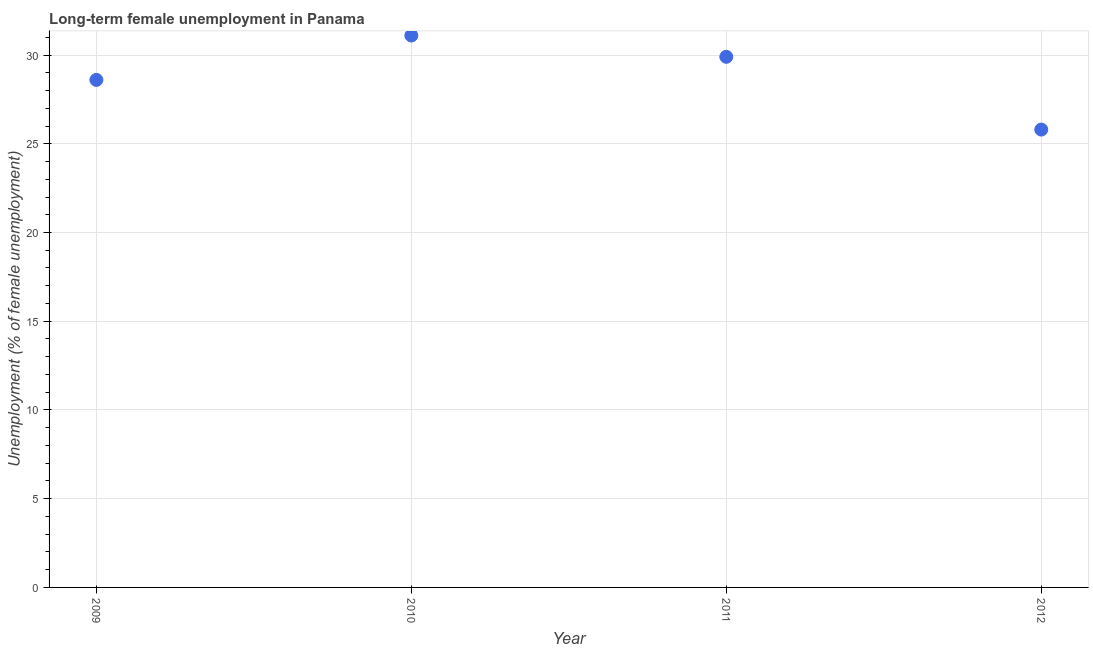What is the long-term female unemployment in 2010?
Provide a short and direct response. 31.1. Across all years, what is the maximum long-term female unemployment?
Ensure brevity in your answer.  31.1. Across all years, what is the minimum long-term female unemployment?
Ensure brevity in your answer.  25.8. In which year was the long-term female unemployment maximum?
Provide a succinct answer. 2010. What is the sum of the long-term female unemployment?
Provide a succinct answer. 115.4. What is the difference between the long-term female unemployment in 2010 and 2011?
Offer a very short reply. 1.2. What is the average long-term female unemployment per year?
Offer a very short reply. 28.85. What is the median long-term female unemployment?
Provide a short and direct response. 29.25. Do a majority of the years between 2012 and 2011 (inclusive) have long-term female unemployment greater than 29 %?
Ensure brevity in your answer.  No. What is the ratio of the long-term female unemployment in 2010 to that in 2012?
Offer a very short reply. 1.21. Is the long-term female unemployment in 2009 less than that in 2012?
Give a very brief answer. No. What is the difference between the highest and the second highest long-term female unemployment?
Give a very brief answer. 1.2. Is the sum of the long-term female unemployment in 2009 and 2010 greater than the maximum long-term female unemployment across all years?
Offer a terse response. Yes. What is the difference between the highest and the lowest long-term female unemployment?
Provide a succinct answer. 5.3. How many dotlines are there?
Your answer should be very brief. 1. Does the graph contain any zero values?
Keep it short and to the point. No. Does the graph contain grids?
Keep it short and to the point. Yes. What is the title of the graph?
Your answer should be compact. Long-term female unemployment in Panama. What is the label or title of the X-axis?
Your response must be concise. Year. What is the label or title of the Y-axis?
Provide a succinct answer. Unemployment (% of female unemployment). What is the Unemployment (% of female unemployment) in 2009?
Keep it short and to the point. 28.6. What is the Unemployment (% of female unemployment) in 2010?
Provide a succinct answer. 31.1. What is the Unemployment (% of female unemployment) in 2011?
Keep it short and to the point. 29.9. What is the Unemployment (% of female unemployment) in 2012?
Your answer should be compact. 25.8. What is the difference between the Unemployment (% of female unemployment) in 2009 and 2011?
Provide a succinct answer. -1.3. What is the difference between the Unemployment (% of female unemployment) in 2010 and 2011?
Your answer should be very brief. 1.2. What is the difference between the Unemployment (% of female unemployment) in 2010 and 2012?
Offer a terse response. 5.3. What is the ratio of the Unemployment (% of female unemployment) in 2009 to that in 2012?
Offer a very short reply. 1.11. What is the ratio of the Unemployment (% of female unemployment) in 2010 to that in 2011?
Provide a short and direct response. 1.04. What is the ratio of the Unemployment (% of female unemployment) in 2010 to that in 2012?
Make the answer very short. 1.21. What is the ratio of the Unemployment (% of female unemployment) in 2011 to that in 2012?
Your answer should be very brief. 1.16. 